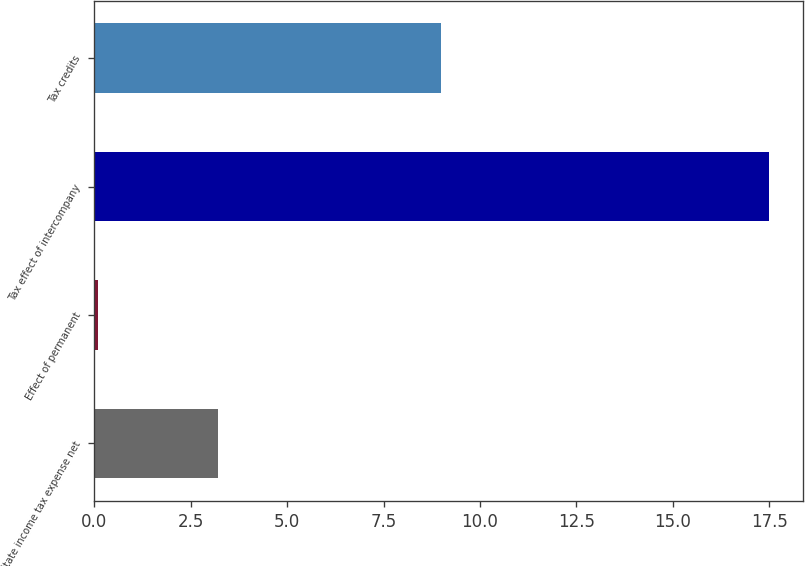Convert chart. <chart><loc_0><loc_0><loc_500><loc_500><bar_chart><fcel>State income tax expense net<fcel>Effect of permanent<fcel>Tax effect of intercompany<fcel>Tax credits<nl><fcel>3.2<fcel>0.1<fcel>17.5<fcel>9<nl></chart> 